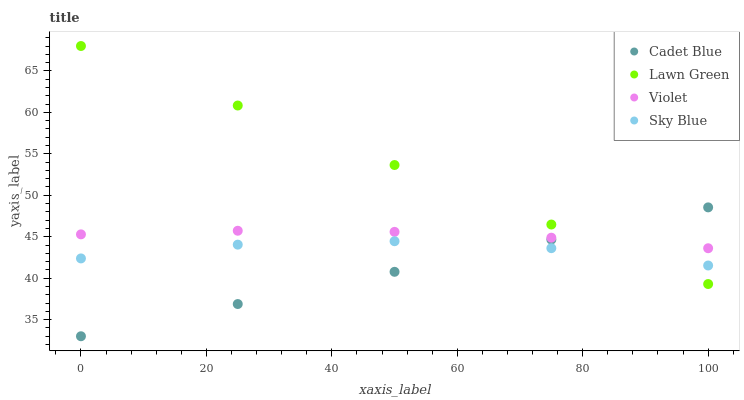Does Cadet Blue have the minimum area under the curve?
Answer yes or no. Yes. Does Lawn Green have the maximum area under the curve?
Answer yes or no. Yes. Does Sky Blue have the minimum area under the curve?
Answer yes or no. No. Does Sky Blue have the maximum area under the curve?
Answer yes or no. No. Is Cadet Blue the smoothest?
Answer yes or no. Yes. Is Sky Blue the roughest?
Answer yes or no. Yes. Is Sky Blue the smoothest?
Answer yes or no. No. Is Cadet Blue the roughest?
Answer yes or no. No. Does Cadet Blue have the lowest value?
Answer yes or no. Yes. Does Sky Blue have the lowest value?
Answer yes or no. No. Does Lawn Green have the highest value?
Answer yes or no. Yes. Does Cadet Blue have the highest value?
Answer yes or no. No. Is Sky Blue less than Violet?
Answer yes or no. Yes. Is Violet greater than Sky Blue?
Answer yes or no. Yes. Does Cadet Blue intersect Sky Blue?
Answer yes or no. Yes. Is Cadet Blue less than Sky Blue?
Answer yes or no. No. Is Cadet Blue greater than Sky Blue?
Answer yes or no. No. Does Sky Blue intersect Violet?
Answer yes or no. No. 